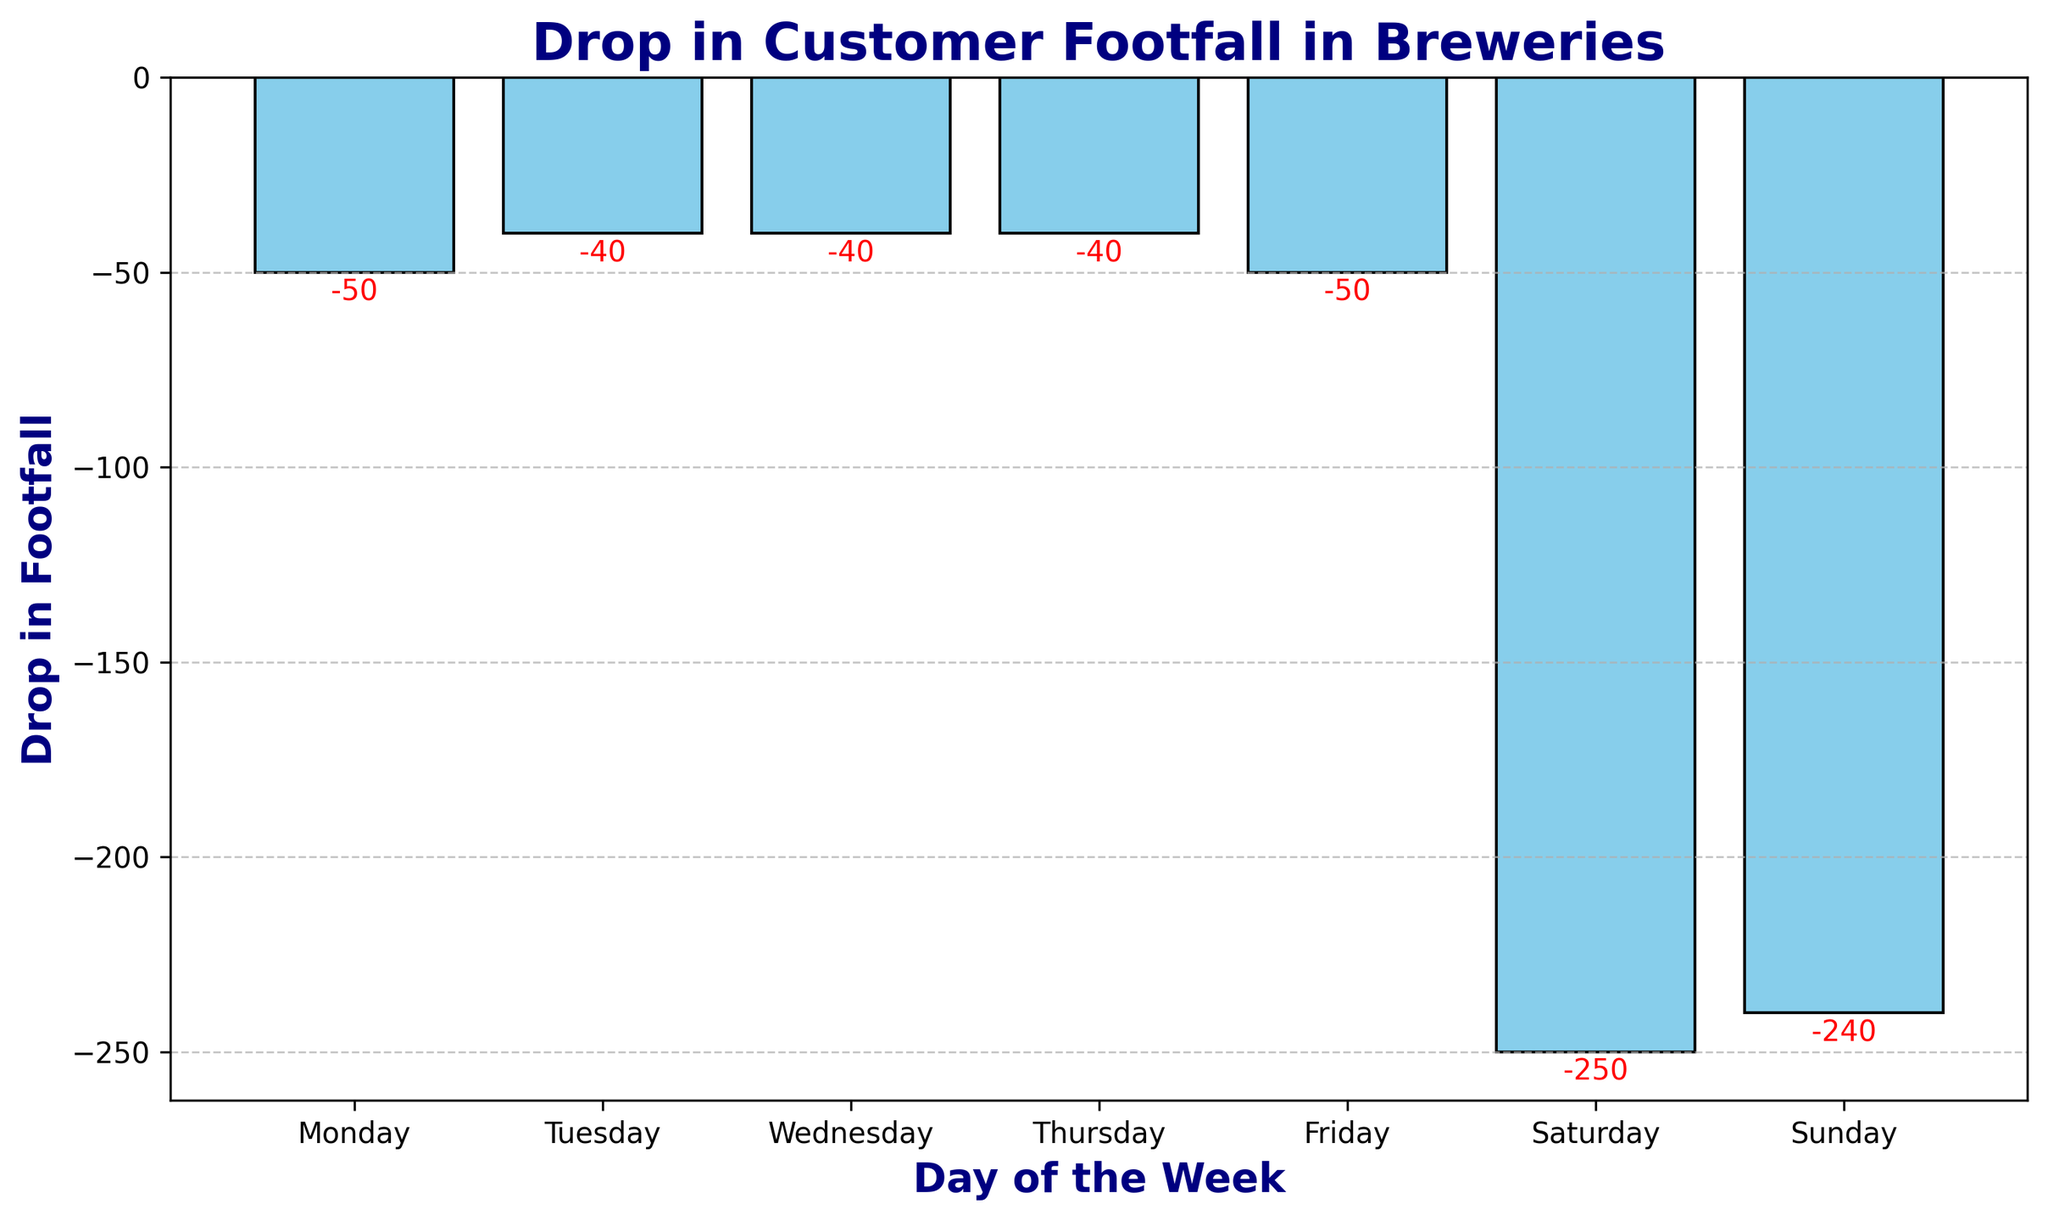What is the drop in footfall on Saturday? Referring to the bar for Saturday, the drop in footfall is indicated as -250 in red.
Answer: -250 Which day has the smallest drop in footfall? By comparing the heights of all bars, Tuesday, Wednesday, and Thursday have the smallest drop, each at -40.
Answer: Tuesday, Wednesday, Thursday Is the drop in footfall on Sunday greater or smaller than on Friday? The drop on Sunday is -240, which is larger in magnitude (more negative) than the drop on Friday, which is -50.
Answer: Greater What is the total drop in footfall for the weekend (Saturday and Sunday)? Adding the negative values for Saturday (-250) and Sunday (-240), the total drop is -250 + (-240) = -490.
Answer: -490 Compare the drop in footfall between Monday and Thursday. Which day has a greater drop? Comparing the negative values, Monday has a drop of -50, while Thursday has a drop of -40. Thus, Monday has a greater drop.
Answer: Monday What is the average drop in footfall during weekdays (excluding weekends)? Summing the drops from Monday to Friday: -50 + (-40) + (-40) + (-40) + (-50) = -220. There are 5 weekdays, so the average drop: -220 / 5 = -44.
Answer: -44 Which day shows the largest drop in footfall? The tallest bar in the negative direction represents Saturday with a drop of -250.
Answer: Saturday Visually, which days have a more significant drop in footfall based on bar color red? By observing the red annotations, Saturday and Sunday are the days with larger negative values.
Answer: Saturday, Sunday Does the drop in footfall increase or decrease as the week progresses from Monday to Friday? Observing the values from Monday (-50), Tuesday (-40), Wednesday (-40), Thursday (-40), to Friday (-50), there is a general trend of decreasing towards the middle of the week and increasing again by Friday.
Answer: Decrease, then Increase Is the drop in footfall on Wednesday more or less than the average drop of the weekdays? The average drop of the weekdays is -44. The drop in footfall on Wednesday is -40, which is less than the average of -44.
Answer: Less 